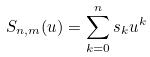<formula> <loc_0><loc_0><loc_500><loc_500>S _ { n , m } ( u ) = \sum _ { k = 0 } ^ { n } s _ { k } u ^ { k }</formula> 